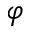<formula> <loc_0><loc_0><loc_500><loc_500>\varphi</formula> 